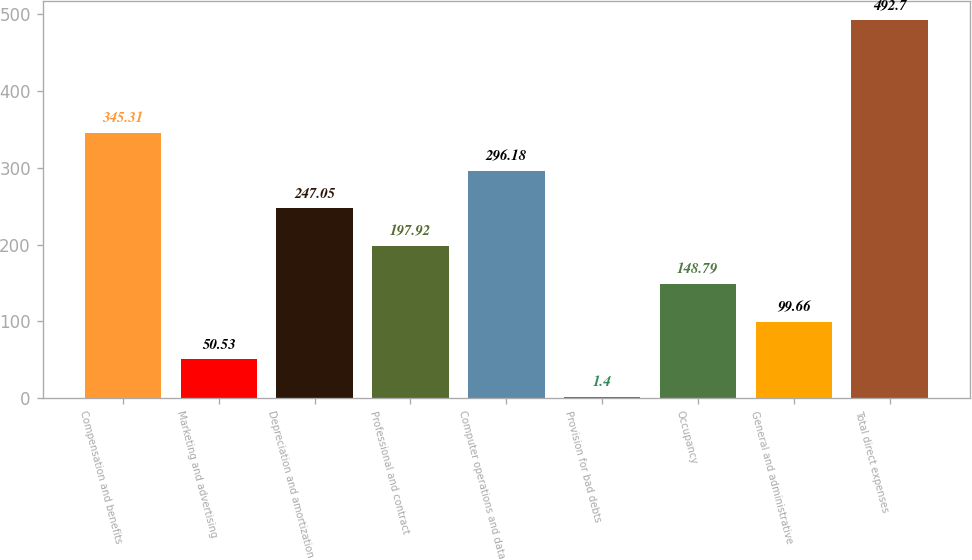<chart> <loc_0><loc_0><loc_500><loc_500><bar_chart><fcel>Compensation and benefits<fcel>Marketing and advertising<fcel>Depreciation and amortization<fcel>Professional and contract<fcel>Computer operations and data<fcel>Provision for bad debts<fcel>Occupancy<fcel>General and administrative<fcel>Total direct expenses<nl><fcel>345.31<fcel>50.53<fcel>247.05<fcel>197.92<fcel>296.18<fcel>1.4<fcel>148.79<fcel>99.66<fcel>492.7<nl></chart> 